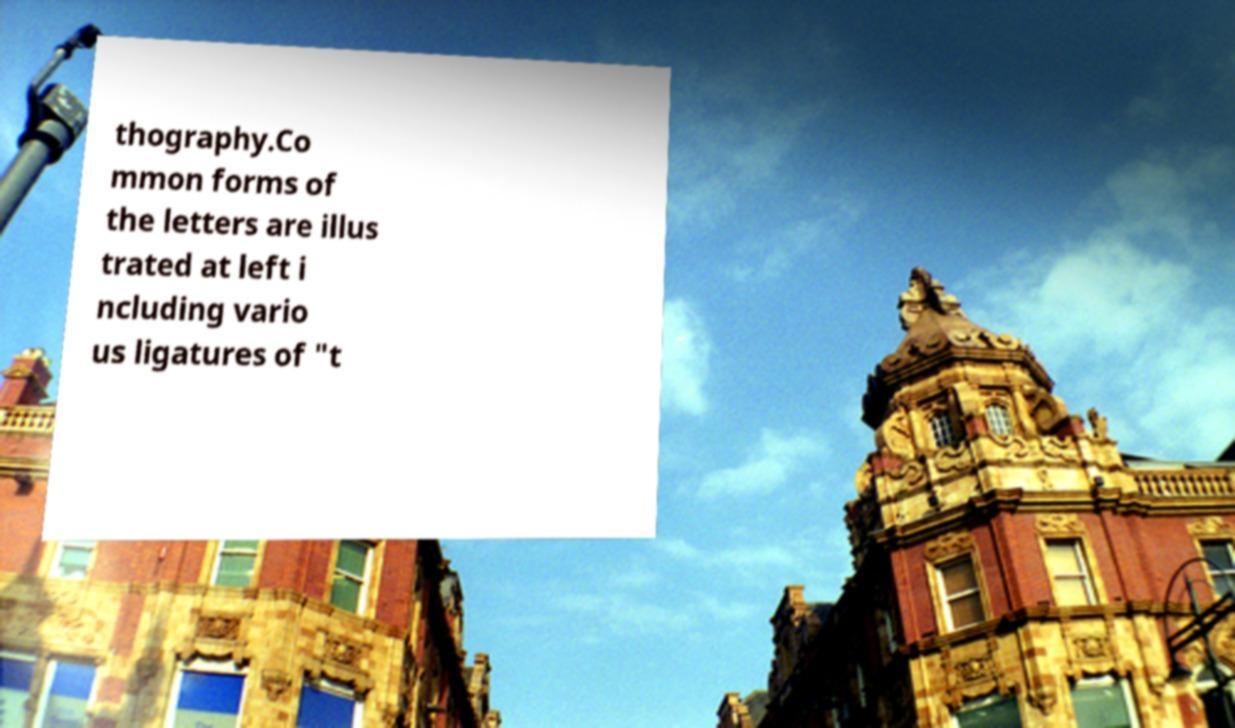I need the written content from this picture converted into text. Can you do that? thography.Co mmon forms of the letters are illus trated at left i ncluding vario us ligatures of "t 